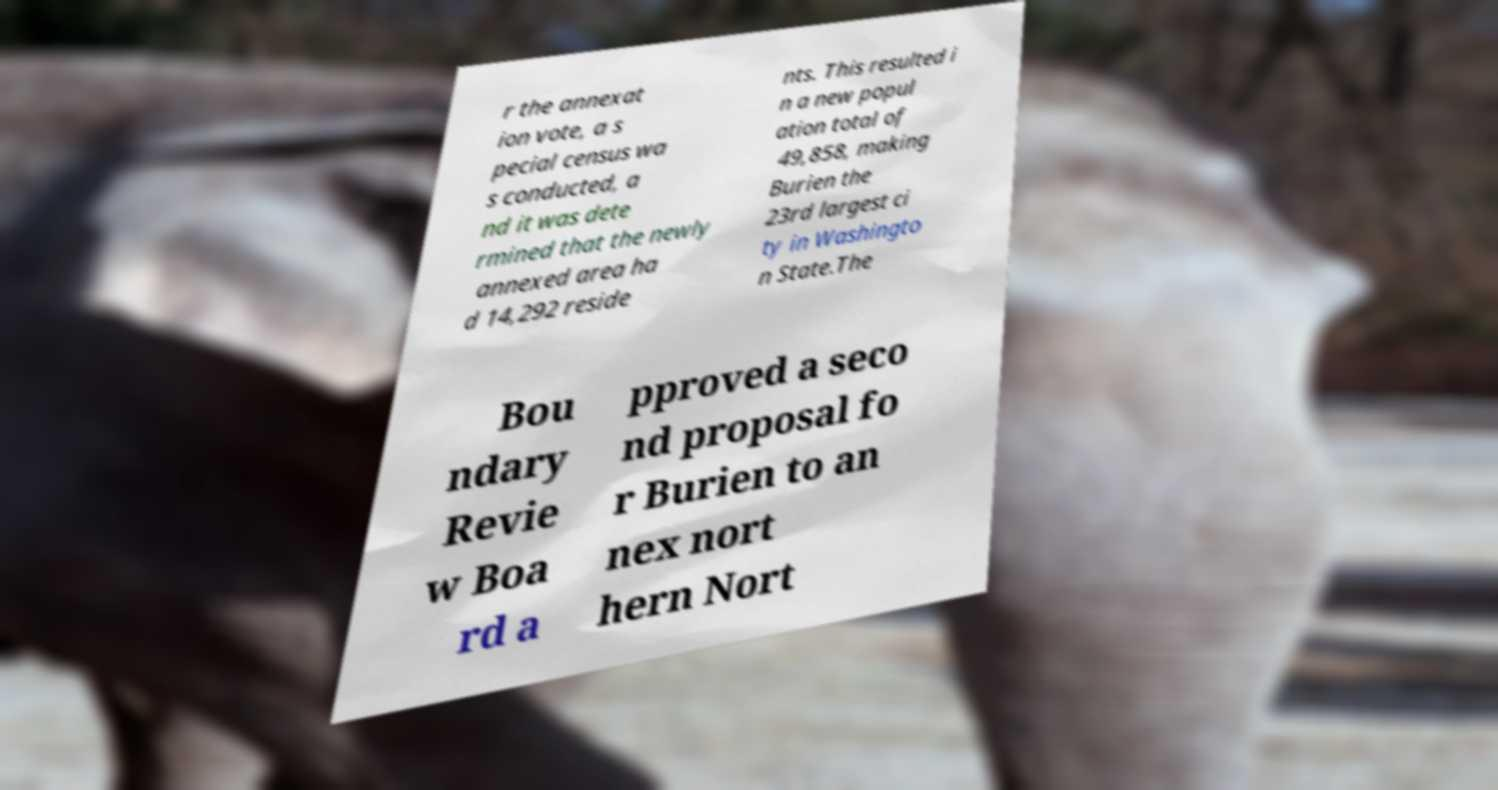Please read and relay the text visible in this image. What does it say? r the annexat ion vote, a s pecial census wa s conducted, a nd it was dete rmined that the newly annexed area ha d 14,292 reside nts. This resulted i n a new popul ation total of 49,858, making Burien the 23rd largest ci ty in Washingto n State.The Bou ndary Revie w Boa rd a pproved a seco nd proposal fo r Burien to an nex nort hern Nort 